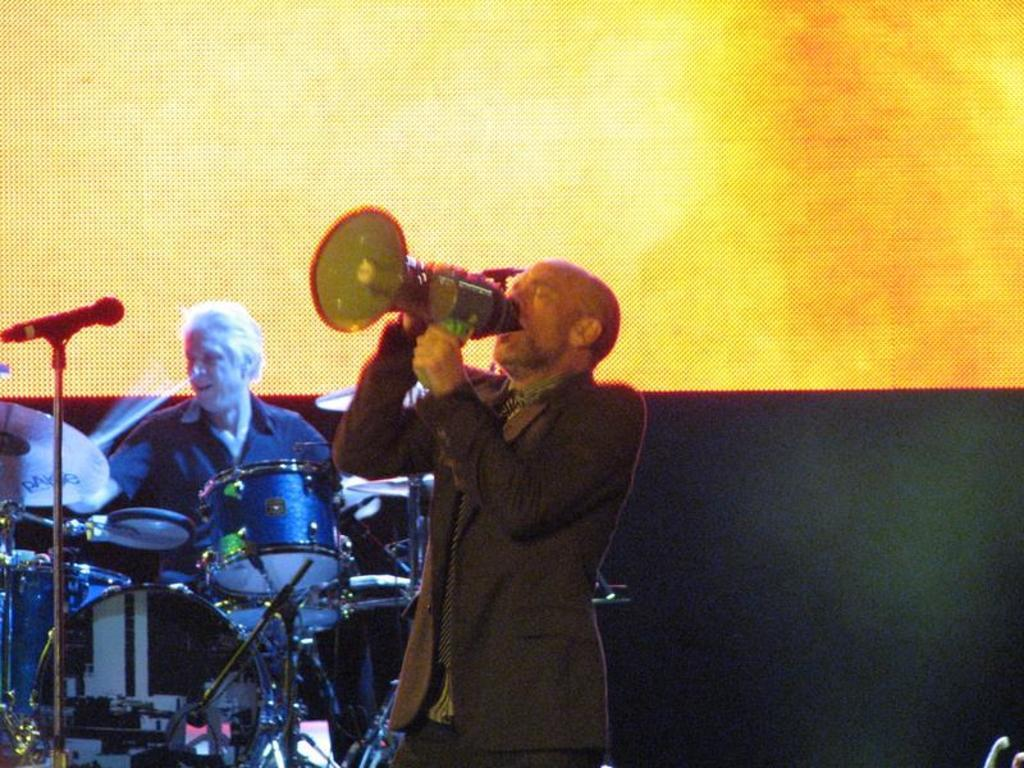What is the man holding in the image? The man is holding a speaker in the image. What is the man doing with the speaker? The man appears to be singing a song while holding the speaker. Are there any other musicians in the image? Yes, there is a man playing drums in the image. Where is the drummer located in the image? The man playing drums is on the left side of the image. Can you see any pancakes floating down the river in the image? There is no river or pancakes present in the image. 